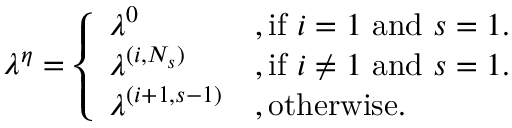<formula> <loc_0><loc_0><loc_500><loc_500>\begin{array} { r } { \lambda ^ { \eta } = \left \{ \begin{array} { l l } { \lambda ^ { 0 } } & { , i f i = 1 a n d s = 1 . } \\ { \lambda ^ { ( i , N _ { s } ) } } & { , i f i \neq 1 a n d s = 1 . } \\ { \lambda ^ { ( i + 1 , s - 1 ) } } & { , o t h e r w i s e . } \end{array} } \end{array}</formula> 